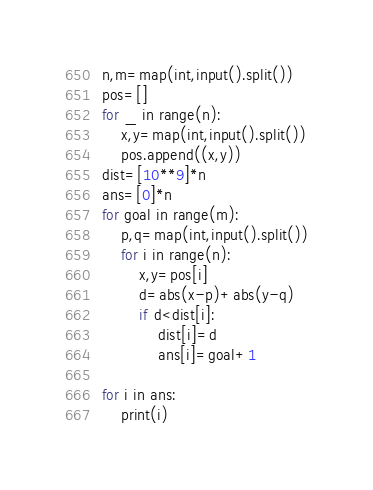<code> <loc_0><loc_0><loc_500><loc_500><_Python_>n,m=map(int,input().split())
pos=[]
for _ in range(n):
    x,y=map(int,input().split())
    pos.append((x,y))
dist=[10**9]*n
ans=[0]*n
for goal in range(m):
    p,q=map(int,input().split())
    for i in range(n):
        x,y=pos[i]
        d=abs(x-p)+abs(y-q)
        if d<dist[i]:
            dist[i]=d
            ans[i]=goal+1

for i in ans:
    print(i)
</code> 